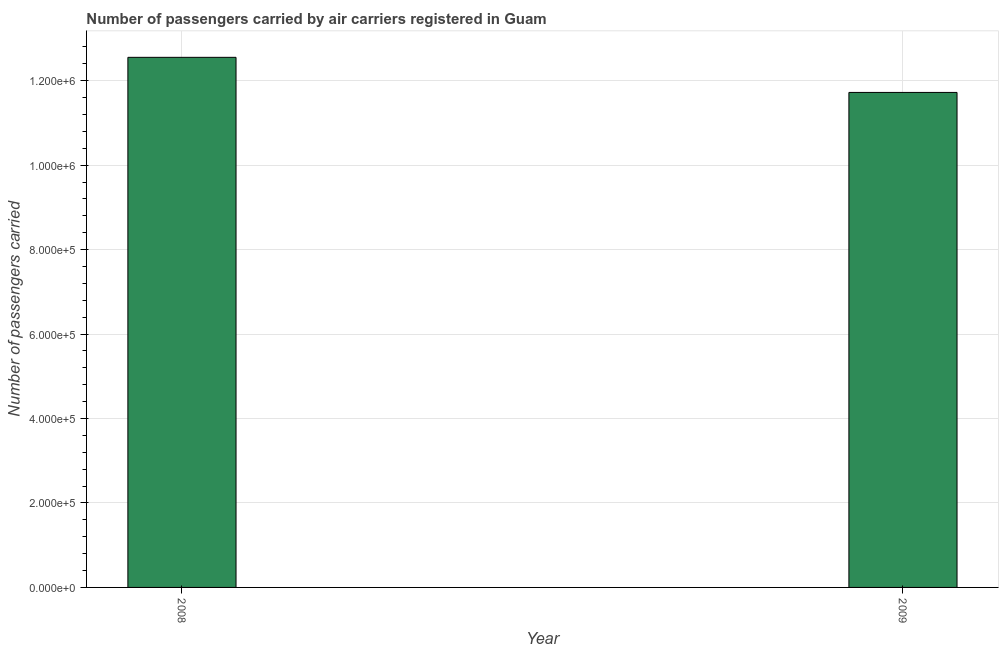What is the title of the graph?
Your response must be concise. Number of passengers carried by air carriers registered in Guam. What is the label or title of the X-axis?
Offer a terse response. Year. What is the label or title of the Y-axis?
Ensure brevity in your answer.  Number of passengers carried. What is the number of passengers carried in 2009?
Offer a very short reply. 1.17e+06. Across all years, what is the maximum number of passengers carried?
Your answer should be very brief. 1.26e+06. Across all years, what is the minimum number of passengers carried?
Keep it short and to the point. 1.17e+06. In which year was the number of passengers carried minimum?
Make the answer very short. 2009. What is the sum of the number of passengers carried?
Provide a succinct answer. 2.43e+06. What is the difference between the number of passengers carried in 2008 and 2009?
Make the answer very short. 8.31e+04. What is the average number of passengers carried per year?
Ensure brevity in your answer.  1.21e+06. What is the median number of passengers carried?
Your answer should be compact. 1.21e+06. Do a majority of the years between 2008 and 2009 (inclusive) have number of passengers carried greater than 720000 ?
Offer a terse response. Yes. What is the ratio of the number of passengers carried in 2008 to that in 2009?
Offer a very short reply. 1.07. Is the number of passengers carried in 2008 less than that in 2009?
Your response must be concise. No. In how many years, is the number of passengers carried greater than the average number of passengers carried taken over all years?
Offer a terse response. 1. How many bars are there?
Provide a succinct answer. 2. Are all the bars in the graph horizontal?
Offer a very short reply. No. Are the values on the major ticks of Y-axis written in scientific E-notation?
Your answer should be very brief. Yes. What is the Number of passengers carried in 2008?
Provide a succinct answer. 1.26e+06. What is the Number of passengers carried of 2009?
Your answer should be very brief. 1.17e+06. What is the difference between the Number of passengers carried in 2008 and 2009?
Your response must be concise. 8.31e+04. What is the ratio of the Number of passengers carried in 2008 to that in 2009?
Make the answer very short. 1.07. 